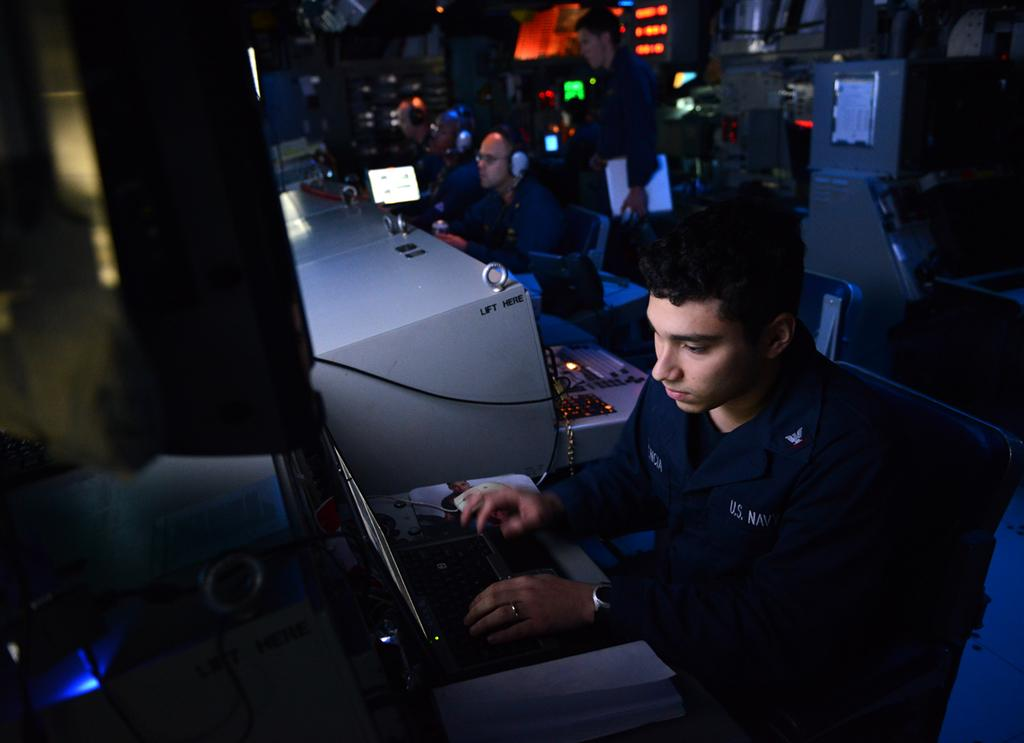What is the man in the image doing? The man is sitting on a chair in the image. What object is on the table in front of the man? There is a laptop on the table in front of the man. What device is used for controlling the laptop? There is a mouse on the table in front of the man. What can be seen in the background of the image? There are people and lights visible in the background. Can you see a bee buzzing around the man's head in the image? No, there is no bee present in the image. What type of cent is visible on the table in front of the man? There is no cent present on the table in the image; only a laptop and a mouse are visible. 